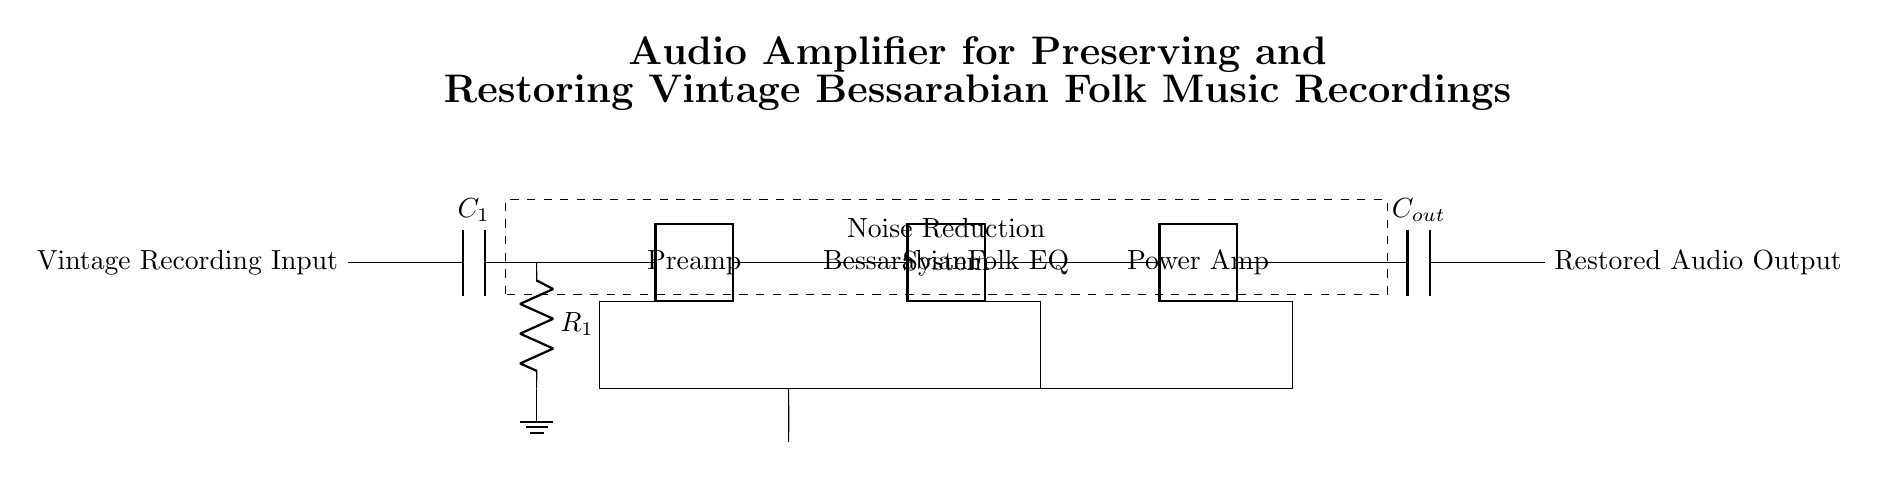What is the input component of this circuit? The input component is labeled as "Vintage Recording Input", which indicates where the audio signal from the vintage recording enters the circuit.
Answer: Vintage Recording Input What type of equalization is used in this amplifier? The equalization component is labeled as "Bessarabian Folk EQ", suggesting that it is specifically designed to enhance the tonal qualities of Bessarabian folk music recordings.
Answer: Bessarabian Folk EQ How many amplification stages are present in the circuit? The circuit diagram includes two amplification stages, specifically labeled as "Preamp" and "Power Amp", indicating the sequence of amplification processes that the signal undergoes.
Answer: Two What is the purpose of the capacitor labeled "C1"? The capacitor "C1" is typically used for coupling, blocking DC while allowing AC signals (the audio signal) to pass through, thus ensuring the correct operation of the amplification stage.
Answer: Coupling What is the function of the dashed rectangle in the circuit? The dashed rectangle is labeled "Noise Reduction System", indicating that it is dedicated to minimizing unwanted noise from the audio signal, enhancing the clarity of the restored recordings.
Answer: Noise Reduction System What is the output of this amplifier circuit? The output component is labeled as "Restored Audio Output", which specifies the point where the amplified and processed signal is made available for playback or further processing.
Answer: Restored Audio Output 